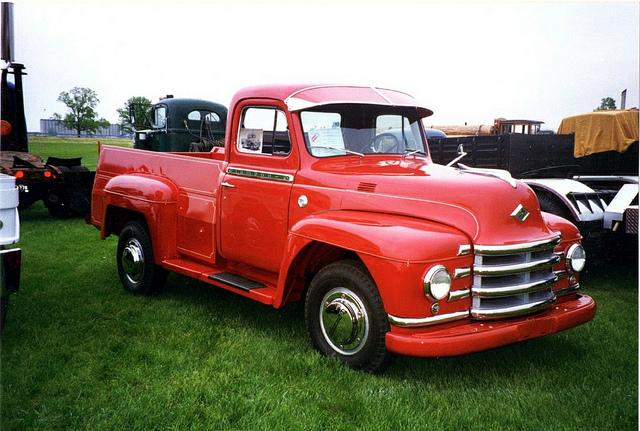What is this red truck for? Please explain your reasoning. sale. The truck is an antique. 